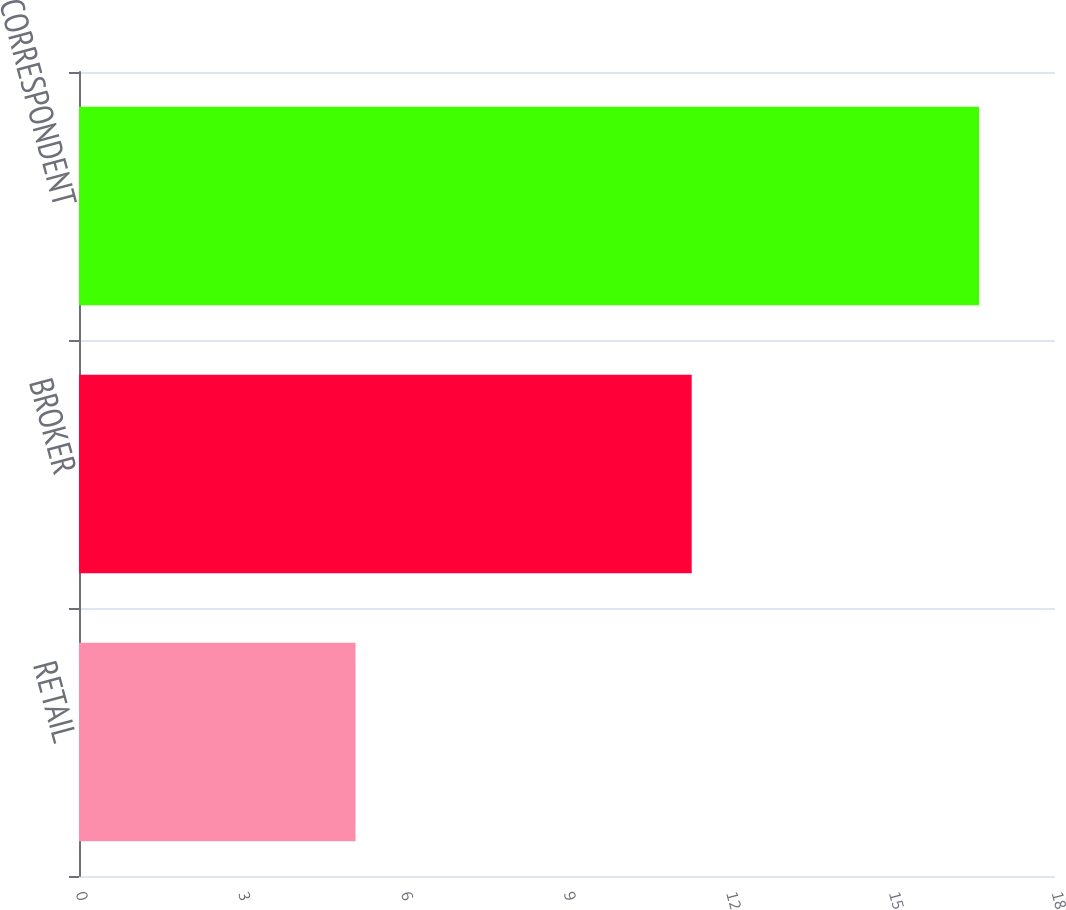Convert chart to OTSL. <chart><loc_0><loc_0><loc_500><loc_500><bar_chart><fcel>RETAIL<fcel>BROKER<fcel>CORRESPONDENT<nl><fcel>5.1<fcel>11.3<fcel>16.6<nl></chart> 